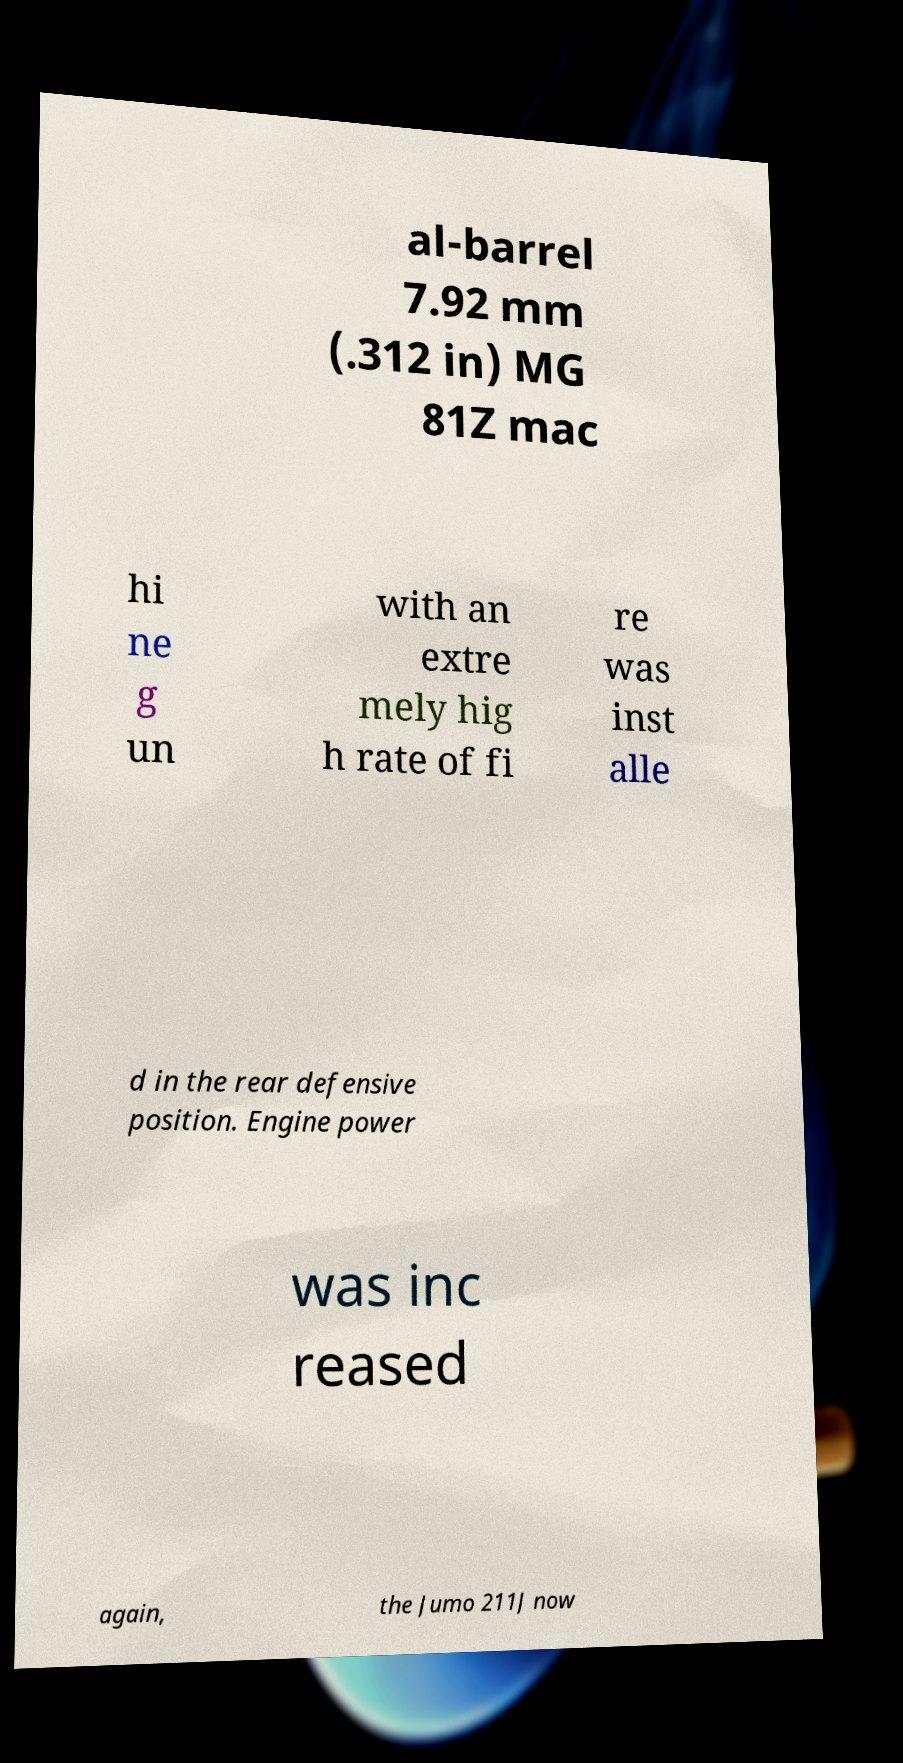What messages or text are displayed in this image? I need them in a readable, typed format. al-barrel 7.92 mm (.312 in) MG 81Z mac hi ne g un with an extre mely hig h rate of fi re was inst alle d in the rear defensive position. Engine power was inc reased again, the Jumo 211J now 